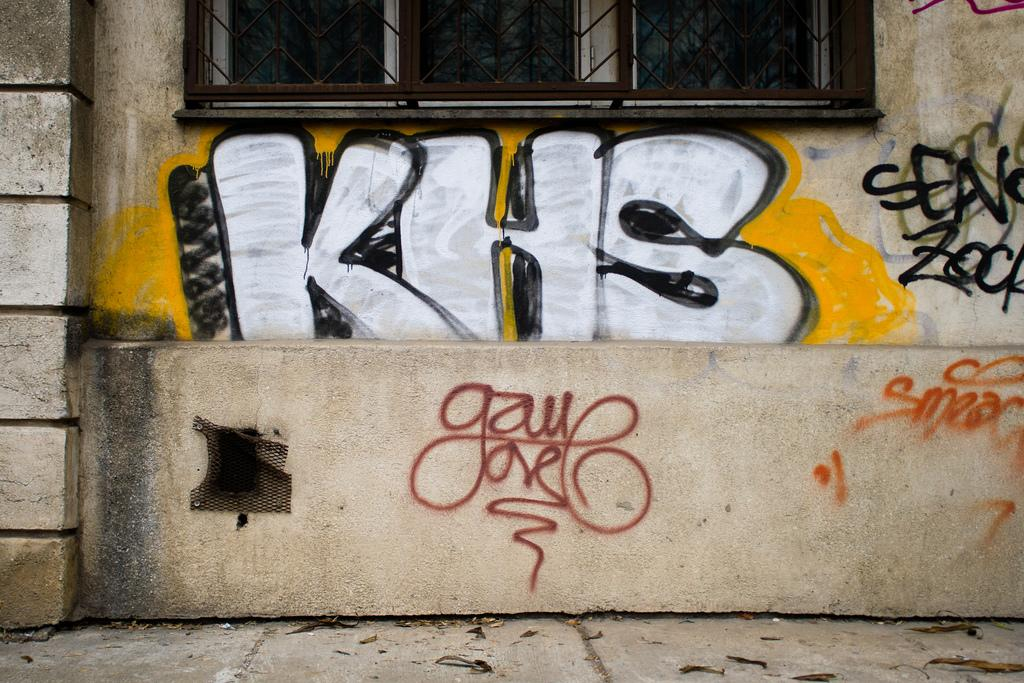What is depicted on the wall in the image? There is a wall with painting and text in the image. What is located at the bottom of the image? There is a walkway at the bottom of the image. What type of architectural feature is visible at the top of the image? Glass windows are visible at the top of the image. What can be seen on the windows at the top of the image? Grills are present at the top of the image. What language is the dress written in? There is no dress present in the image, and therefore no language associated with it. 